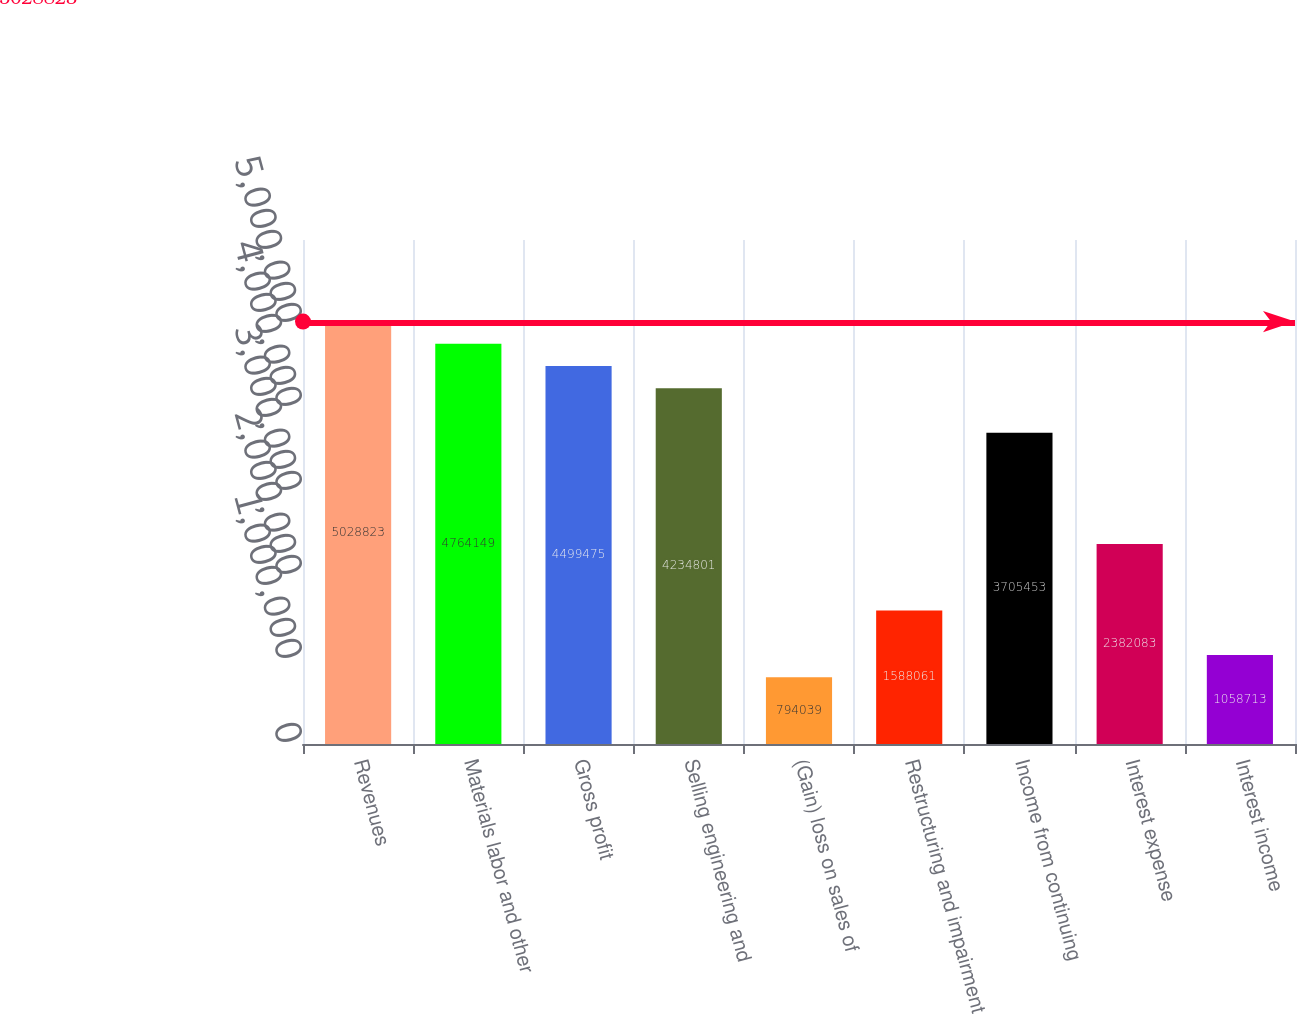<chart> <loc_0><loc_0><loc_500><loc_500><bar_chart><fcel>Revenues<fcel>Materials labor and other<fcel>Gross profit<fcel>Selling engineering and<fcel>(Gain) loss on sales of<fcel>Restructuring and impairment<fcel>Income from continuing<fcel>Interest expense<fcel>Interest income<nl><fcel>5.02882e+06<fcel>4.76415e+06<fcel>4.49948e+06<fcel>4.2348e+06<fcel>794039<fcel>1.58806e+06<fcel>3.70545e+06<fcel>2.38208e+06<fcel>1.05871e+06<nl></chart> 